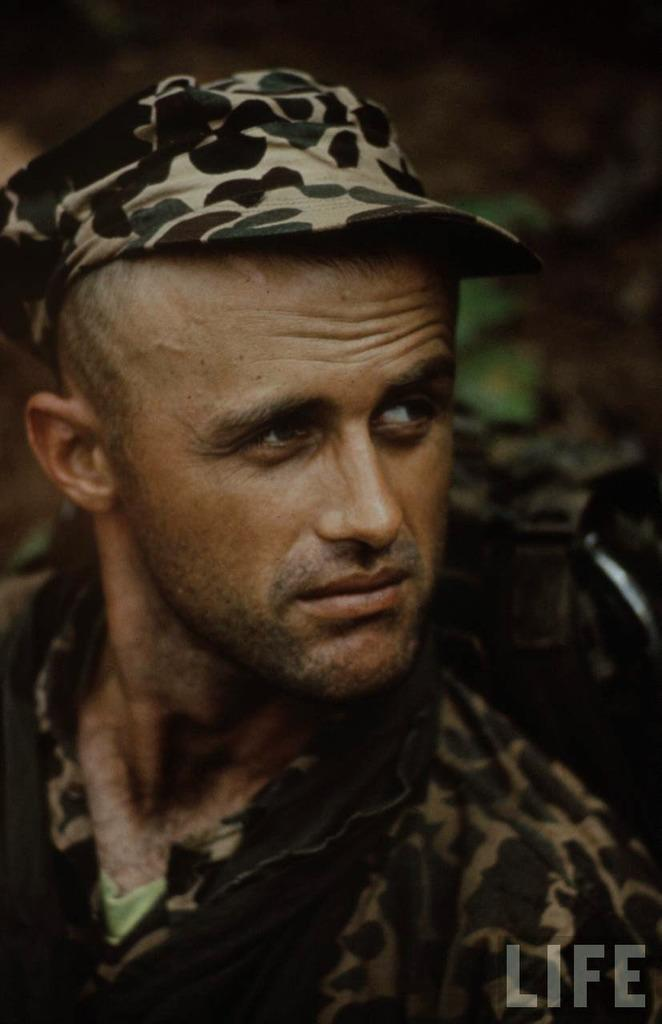What is the man in the picture wearing on his head? The man is wearing a cap. What type of clothing is the man wearing on his upper body? The man is wearing a shirt. What is the man holding in the image? The man is holding a bag. Can you describe any additional features in the image? There is a watermark in the bottom right corner of the image. What is happening in the background of the image? There is a person leaving in the background of the image. What type of root can be seen growing in the image? There is no root visible in the image; it features a man wearing a cap and shirt, holding a bag, and standing in front of a person leaving in the background. 